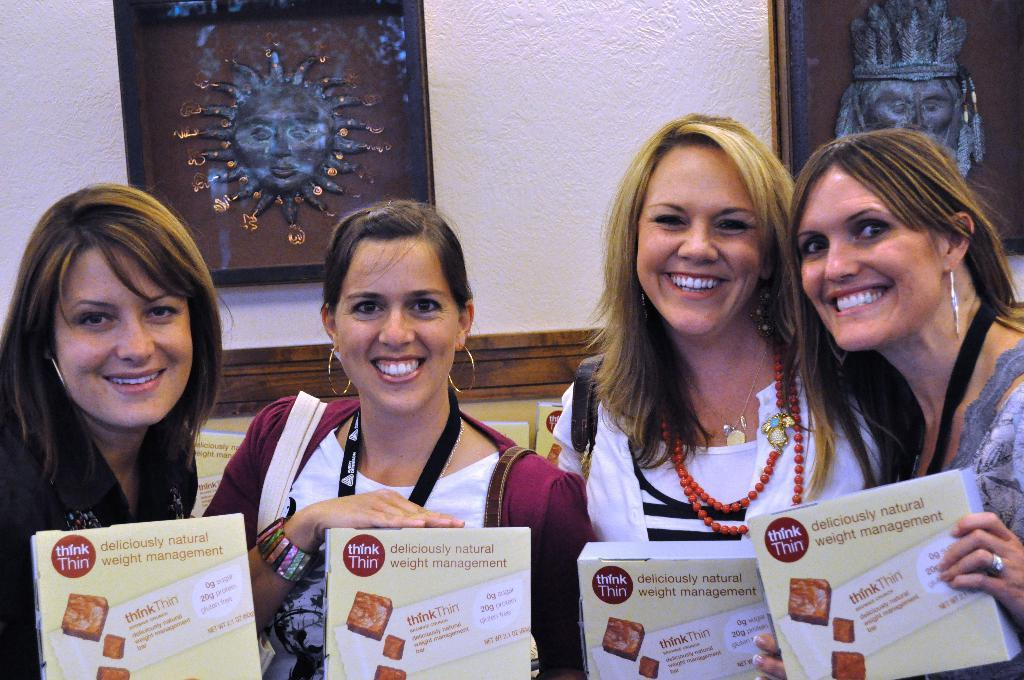Who is present in the image? There are women in the image. What are the women doing in the image? The women are smiling and holding boxes. What can be seen in the background of the image? There is a wall and photo frames in the background of the image. Are there any dogs or signs of thunder in the image? No, there are no dogs or signs of thunder present in the image. 